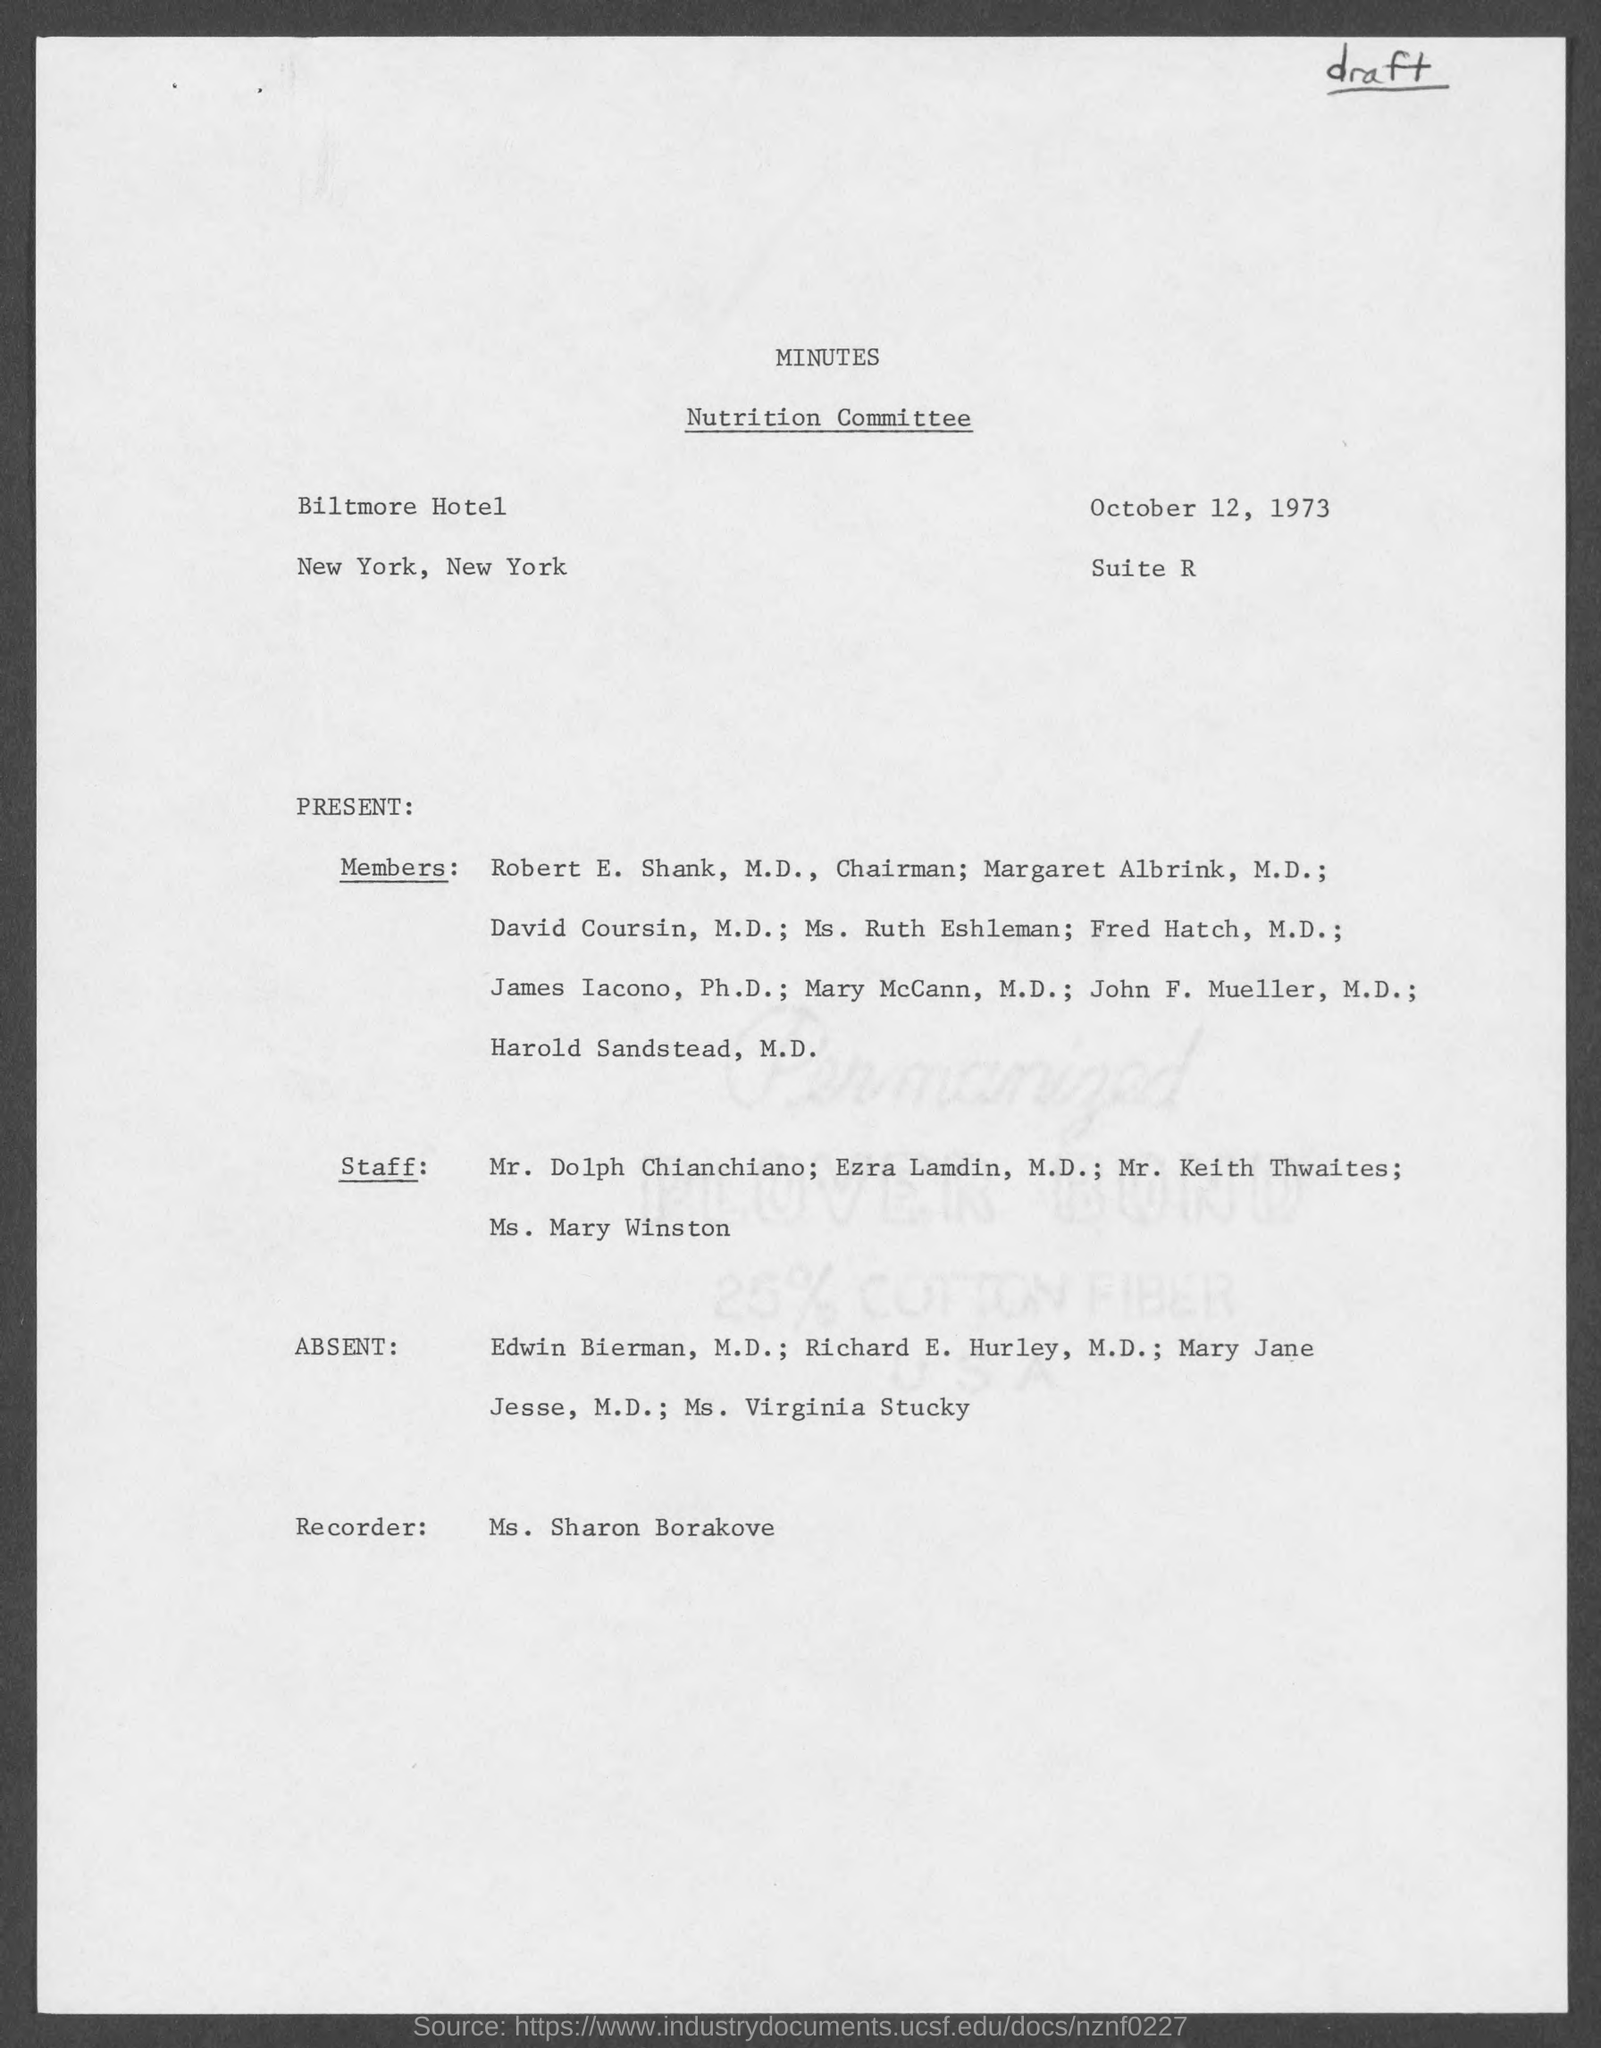What is the title of committee ?
Offer a terse response. Nutrition committee. Who is the recorder in nutrition committee ?
Your response must be concise. Ms. sharon borakove. When is the minutes dated on ?
Provide a succinct answer. October 12, 1973. In which hotel did nutrition committee held at ?
Offer a very short reply. Biltmore hotel. Who is the chairman, nutrition committee ?
Keep it short and to the point. Robert E. Shank, M.D. 